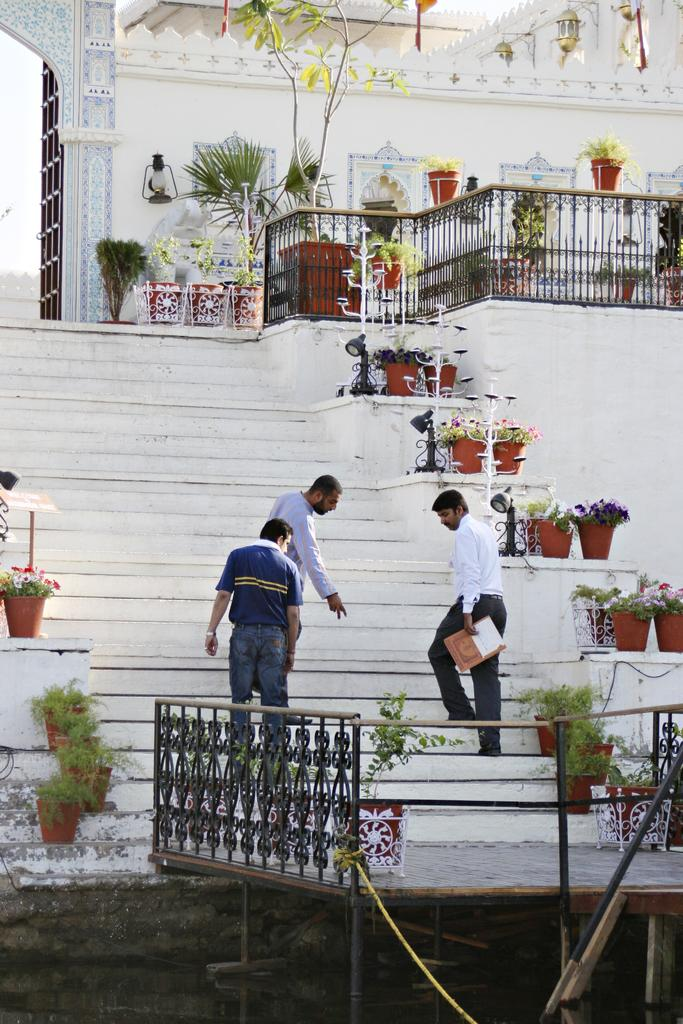How many people are in the image? There are three men in the image. What are the men doing in the image? The men are walking through the stairs. What can be seen at the top of the image? There are plants at the top of the image. What type of structure is visible in the image? There is a building in the image. What is the color of the building? The building is white in color. What time is displayed on the clock in the image? There is no clock present in the image. How many wings does the bird have in the image? There is no bird present in the image. 